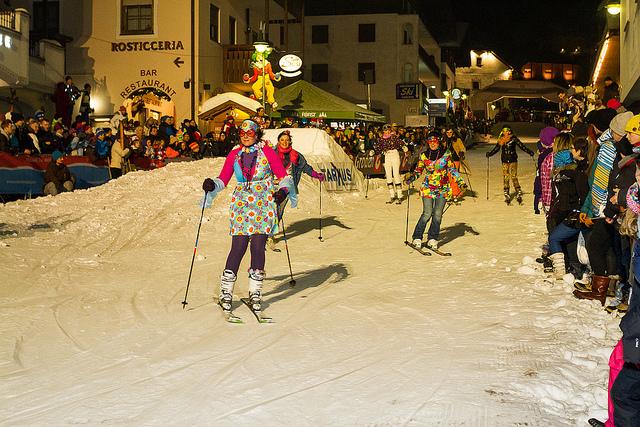Is this a race?
Short answer required. Yes. Is the skier in front wearing traditional ski clothing?
Quick response, please. No. Was this pic taken during the day?
Write a very short answer. No. 